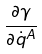<formula> <loc_0><loc_0><loc_500><loc_500>\frac { \partial \gamma } { \partial \dot { q } ^ { A } }</formula> 